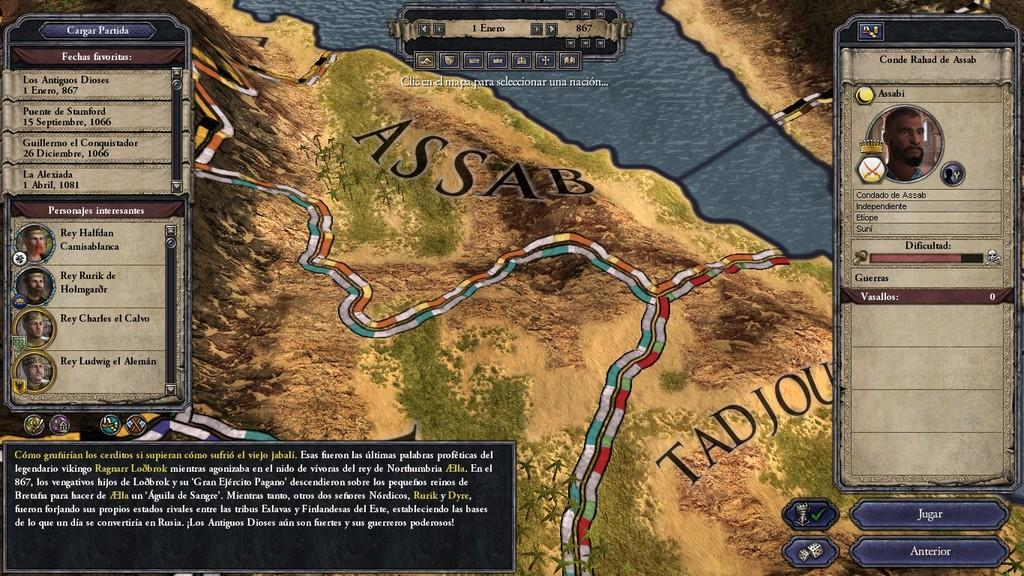What type of image is being shown? The image is a screenshot of a game. Can you describe any characters or elements within the game? There are people's faces visible in the image. Is there any text present in the image? Yes, there is text written on the image. How would you describe the overall appearance of the image? The image is colorful. What type of cub is being cooked by the government in the image? There is no mention of a cub or the government in the image; it is a screenshot of a game with people's faces and text. 